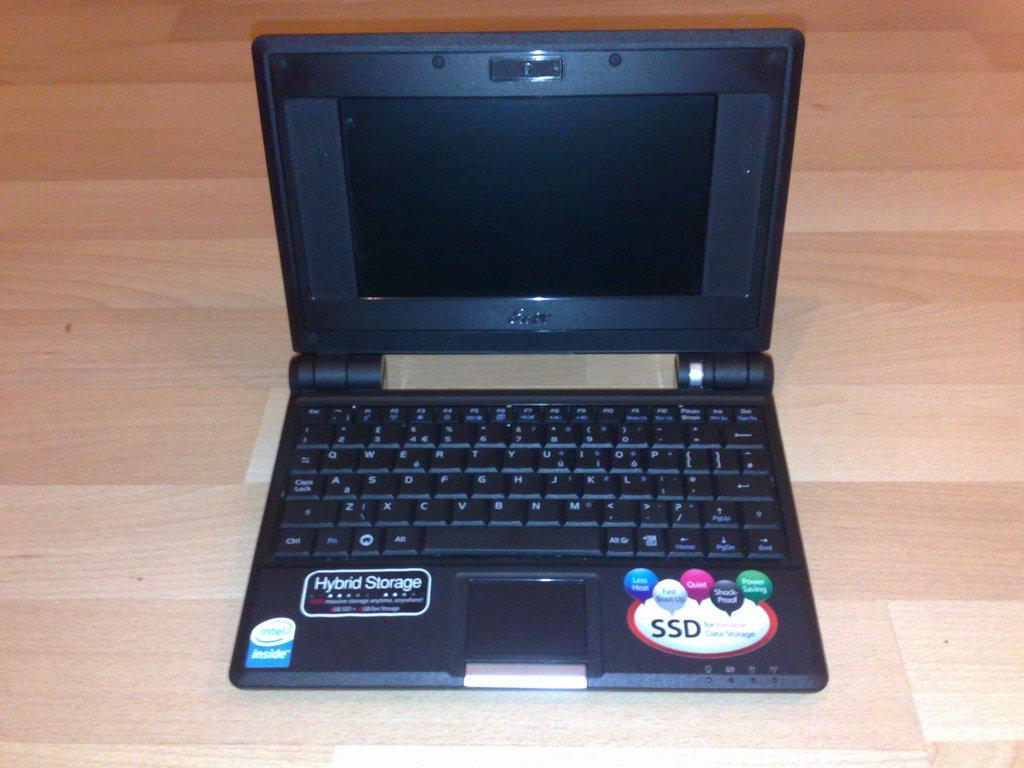<image>
Give a short and clear explanation of the subsequent image. A small laptop has features which include Hybrid Storage and an SSD. 